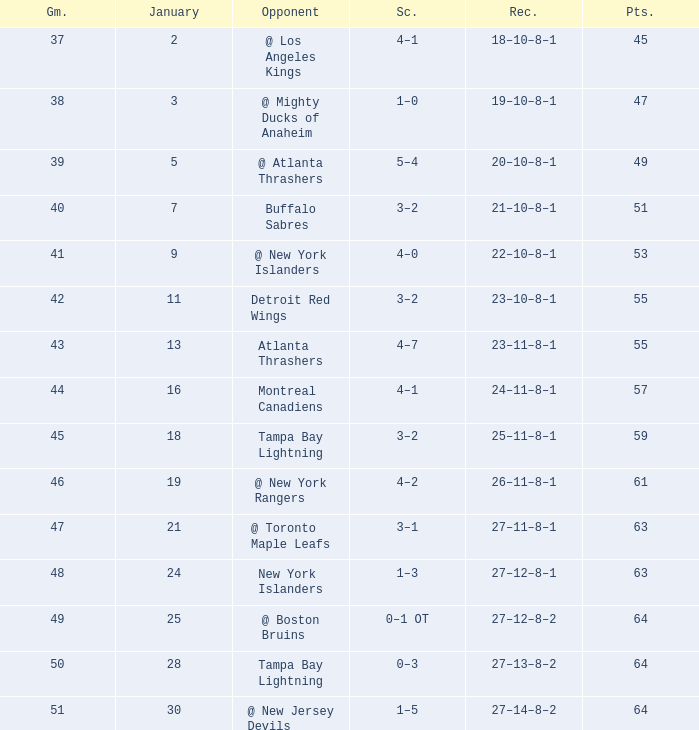How many Points have a January of 18? 1.0. 